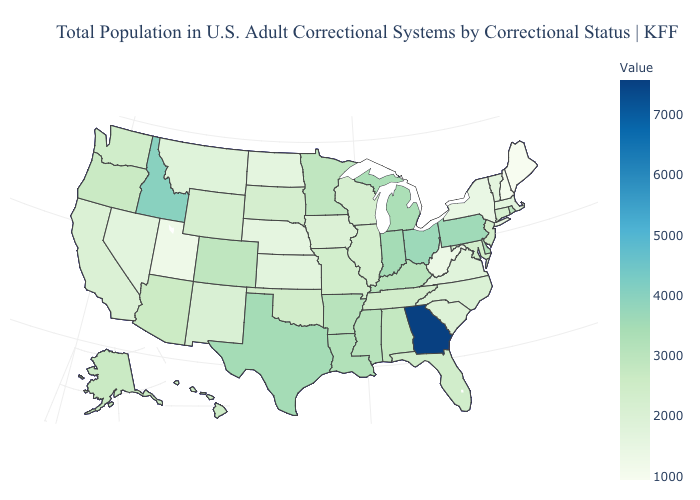Among the states that border North Carolina , which have the lowest value?
Quick response, please. Virginia. Does the map have missing data?
Answer briefly. No. Does Nevada have a lower value than Pennsylvania?
Be succinct. Yes. Which states have the lowest value in the South?
Write a very short answer. West Virginia. Among the states that border Nevada , which have the lowest value?
Answer briefly. Utah. Is the legend a continuous bar?
Quick response, please. Yes. Is the legend a continuous bar?
Write a very short answer. Yes. 